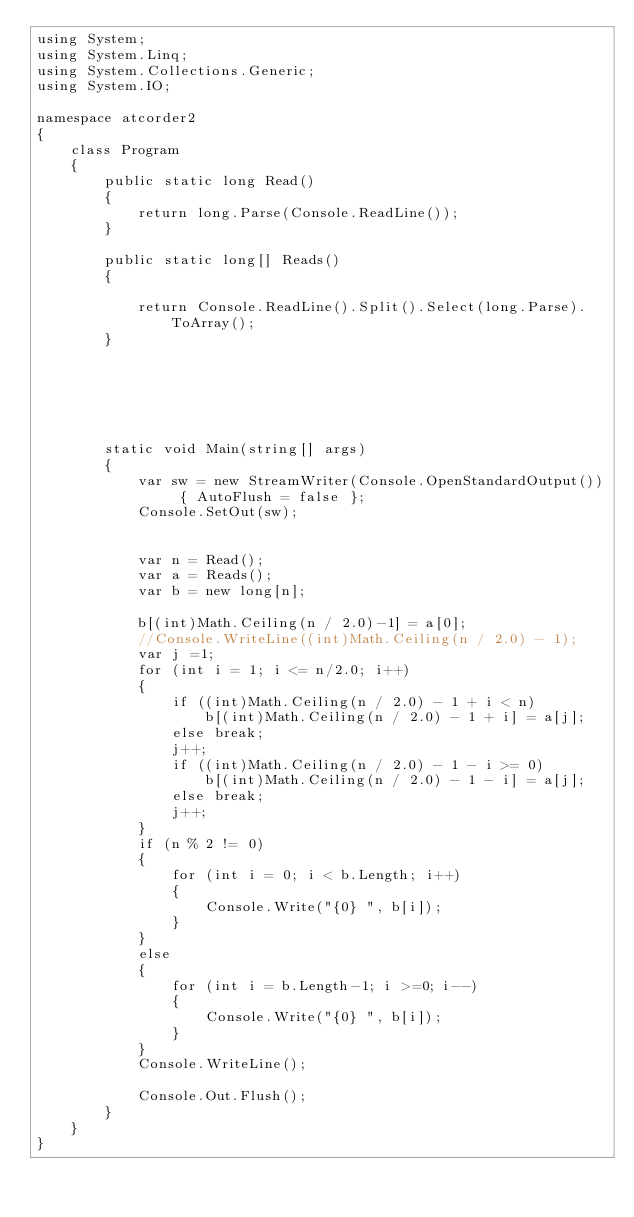Convert code to text. <code><loc_0><loc_0><loc_500><loc_500><_C#_>using System;
using System.Linq;
using System.Collections.Generic;
using System.IO;

namespace atcorder2
{
    class Program
    {
        public static long Read()
        {
            return long.Parse(Console.ReadLine());
        }

        public static long[] Reads()
        {

            return Console.ReadLine().Split().Select(long.Parse).ToArray();
        }






        static void Main(string[] args)
        {
            var sw = new StreamWriter(Console.OpenStandardOutput()) { AutoFlush = false };
            Console.SetOut(sw);


            var n = Read();
            var a = Reads();
            var b = new long[n];

            b[(int)Math.Ceiling(n / 2.0)-1] = a[0];
            //Console.WriteLine((int)Math.Ceiling(n / 2.0) - 1);
            var j =1;
            for (int i = 1; i <= n/2.0; i++)
            {
                if ((int)Math.Ceiling(n / 2.0) - 1 + i < n)
                    b[(int)Math.Ceiling(n / 2.0) - 1 + i] = a[j];
                else break;
                j++;
                if ((int)Math.Ceiling(n / 2.0) - 1 - i >= 0)
                    b[(int)Math.Ceiling(n / 2.0) - 1 - i] = a[j];
                else break;
                j++;
            }
            if (n % 2 != 0)
            {
                for (int i = 0; i < b.Length; i++)
                {
                    Console.Write("{0} ", b[i]);
                }
            }
            else
            {
                for (int i = b.Length-1; i >=0; i--)
                {
                    Console.Write("{0} ", b[i]);
                }
            }
            Console.WriteLine();
         
            Console.Out.Flush();
        }
    }
}


</code> 